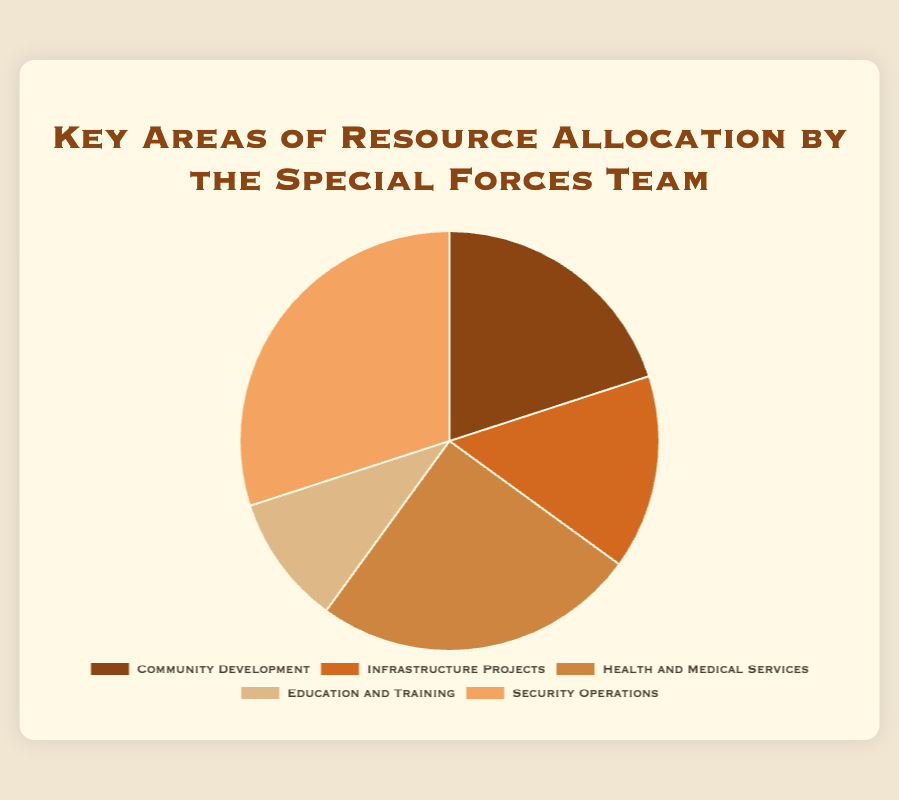Which area receives the highest allocation of resources? Inspect the pie chart to determine the segment with the largest proportion. The 'Security Operations' section occupies the most space of the chart.
Answer: Security Operations What is the total resource allocation percentage for Community Development and Infrastructure Projects combined? Add the percentages of 'Community Development' (20%) and 'Infrastructure Projects' (15%). 20 + 15 = 35
Answer: 35 How much more is allocated to Health and Medical Services compared to Education and Training? Subtract the percentage of 'Education and Training' (10%) from that of 'Health and Medical Services' (25%). 25 - 10 = 15
Answer: 15 Which area has the second lowest allocation of resources? Examine the pie chart to identify the second smallest segment. 'Infrastructure Projects' is larger than 'Education and Training' but smaller than the others.
Answer: Infrastructure Projects What is the total percentage of resources allocated to non-security operations? Subtract the allocation for 'Security Operations' (30%) from 100%. 100 - 30 = 70
Answer: 70 If the allocations for Health and Medical Services and Security Operations were combined, what percentage of the total resources would they represent? Add the percentages for 'Health and Medical Services' (25%) and 'Security Operations' (30%). 25 + 30 = 55
Answer: 55 What color represents Infrastructure Projects in the pie chart? Observe the visual attributes of the pie chart. The slice representing 'Infrastructure Projects' is light brown.
Answer: Light brown Compare the allocations of Education and Training to Community Development. Which is greater and by how much? Subtract the percentage for 'Education and Training' (10%) from 'Community Development' (20%). 20 - 10 = 10
Answer: Community Development; 10 What is the average percentage allocation for the five key areas? Sum the percentages of all areas and divide by the number of areas: (20 + 15 + 25 + 10 + 30) / 5. 100 / 5 = 20
Answer: 20 